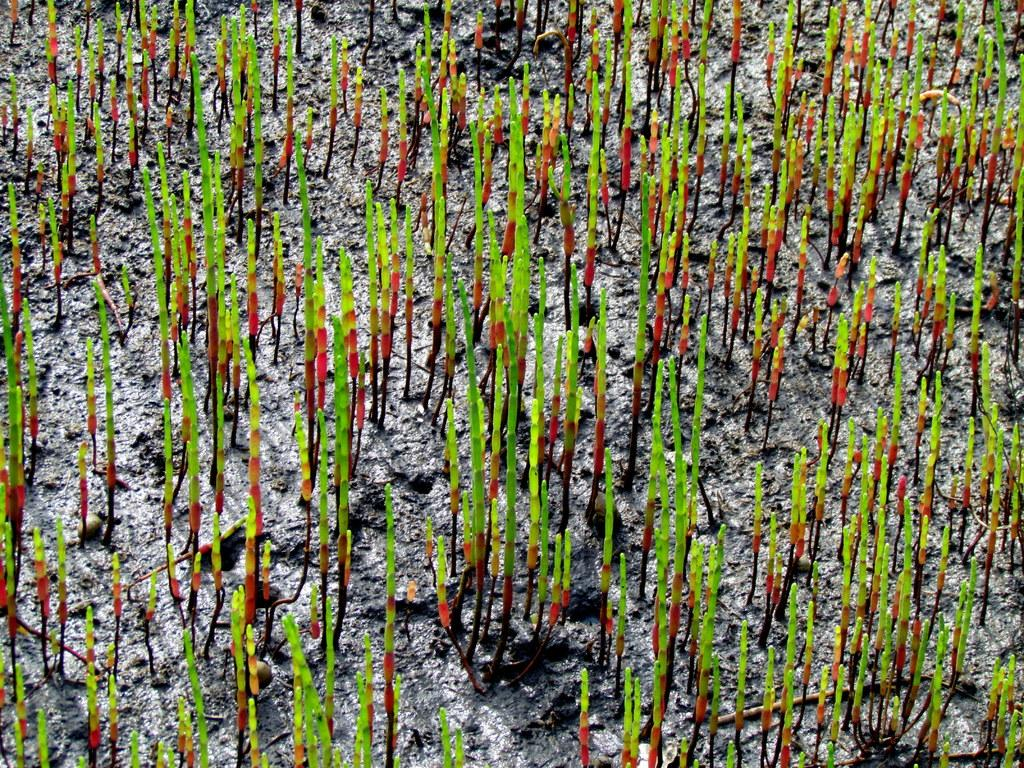What type of landscape is depicted in the image? There is a field in the image. What distinguishes this field from a typical field? The field has multicolored elements. How many cakes are present in the field in the image? There are no cakes present in the field in the image. What type of trouble might the multicolored elements in the field be causing? The image does not provide any information about the multicolored elements causing trouble. 